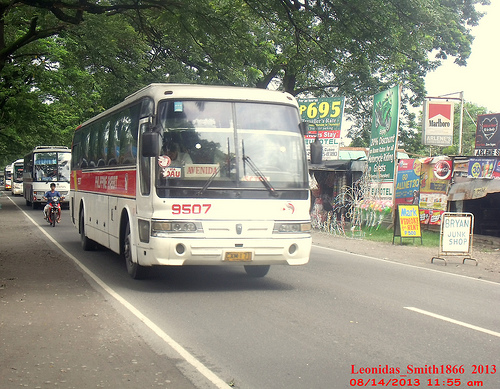What do you think the text on the green road sign says? The green road sign seems to have multiple advertisements and notices. It likely includes various business names, products, and directional information for travelers on the road. Do you think this image captures a city or a countryside atmosphere? The image captures a mix of both urban and countryside atmospheres. The presence of multiple buses and numerous advertisements suggest a busy area, potentially leaning towards a more urban setting, but the overhead green trees provide a serene, countryside feel. Imagine if the buses were instead carriages led by horses, how would this scene change? Replacing the buses with horse-drawn carriages would transform the scene into something reminiscent of the past. There would be a quieter, more tranquil atmosphere as the carriages trotted along an unpaved road. The roadside signs might be less commercial and more quaint, announcing local fairs or markets. The whole scene would evoke a sense of nostalgia and simpler times. What type of stories could unfold around this busy roadside scene? Many stories could unfold around this roadside scene. Perhaps it's the meeting spot for a group of friends planning a road trip, or a place where a young child gets lost and is found by a kind stranger. Maybe it's the scene of a reunion or where an important meeting takes place. The bustling activity and varied elements make it rich with potential narratives waiting to be explored. 